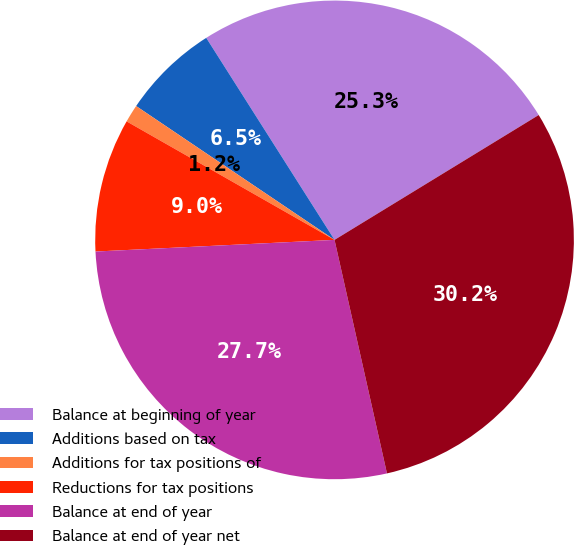Convert chart. <chart><loc_0><loc_0><loc_500><loc_500><pie_chart><fcel>Balance at beginning of year<fcel>Additions based on tax<fcel>Additions for tax positions of<fcel>Reductions for tax positions<fcel>Balance at end of year<fcel>Balance at end of year net<nl><fcel>25.27%<fcel>6.55%<fcel>1.2%<fcel>9.02%<fcel>27.74%<fcel>30.22%<nl></chart> 